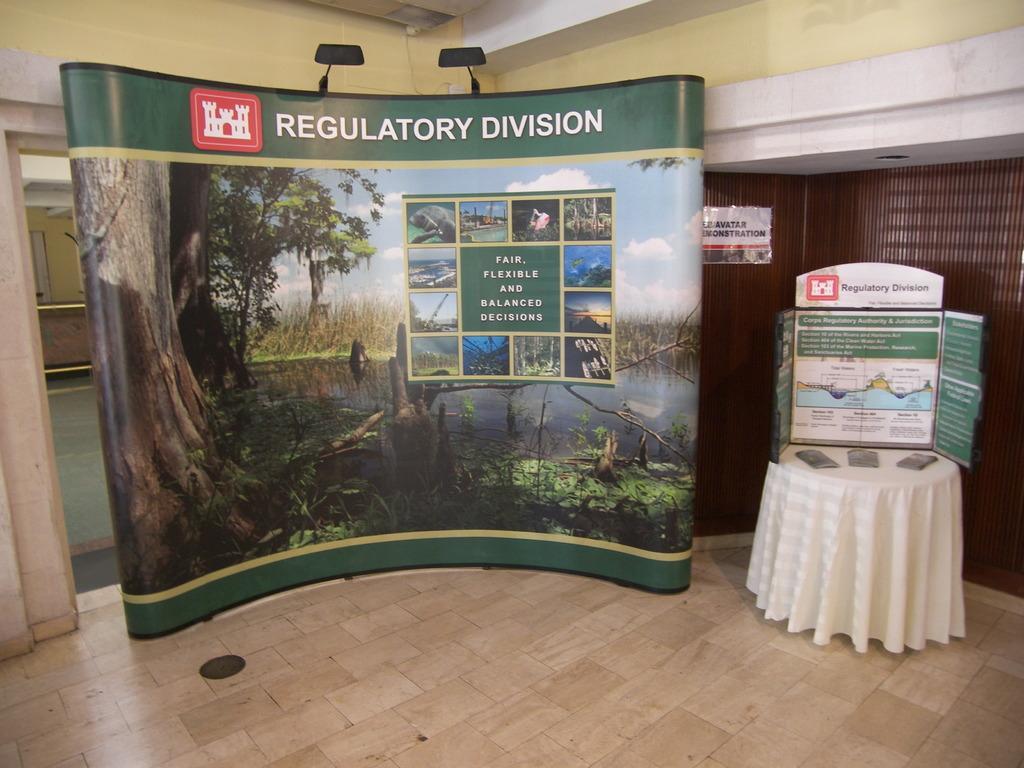Can you describe this image briefly? In this picture it looks like a banner in the middle, on the right side there are papers on a table. In the background there are walls. 